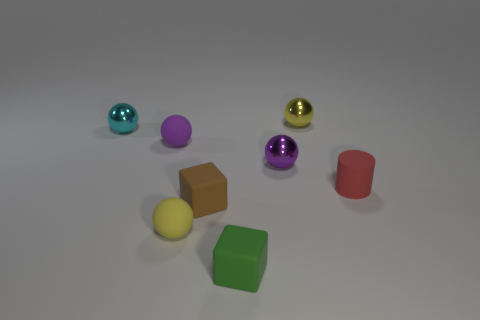Subtract 1 spheres. How many spheres are left? 4 Subtract all cyan balls. How many balls are left? 4 Subtract all tiny cyan spheres. How many spheres are left? 4 Subtract all green balls. Subtract all cyan cubes. How many balls are left? 5 Add 1 tiny brown blocks. How many objects exist? 9 Subtract all cubes. How many objects are left? 6 Add 6 cyan balls. How many cyan balls are left? 7 Add 8 large cubes. How many large cubes exist? 8 Subtract 0 blue blocks. How many objects are left? 8 Subtract all purple matte spheres. Subtract all big gray balls. How many objects are left? 7 